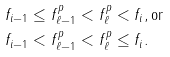<formula> <loc_0><loc_0><loc_500><loc_500>& f _ { i - 1 } \leq f ^ { p } _ { \ell - 1 } < f ^ { p } _ { \ell } < f _ { i } , \text {or} \\ & f _ { i - 1 } < f ^ { p } _ { \ell - 1 } < f ^ { p } _ { \ell } \leq f _ { i } .</formula> 